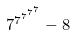<formula> <loc_0><loc_0><loc_500><loc_500>7 ^ { 7 ^ { 7 ^ { 7 ^ { 7 } } } } - 8</formula> 